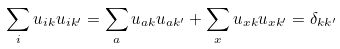Convert formula to latex. <formula><loc_0><loc_0><loc_500><loc_500>\sum _ { i } u _ { i k } u _ { i k ^ { \prime } } = \sum _ { a } u _ { a k } u _ { a k ^ { \prime } } + \sum _ { x } u _ { x k } u _ { x k ^ { \prime } } = \delta _ { k k ^ { \prime } }</formula> 